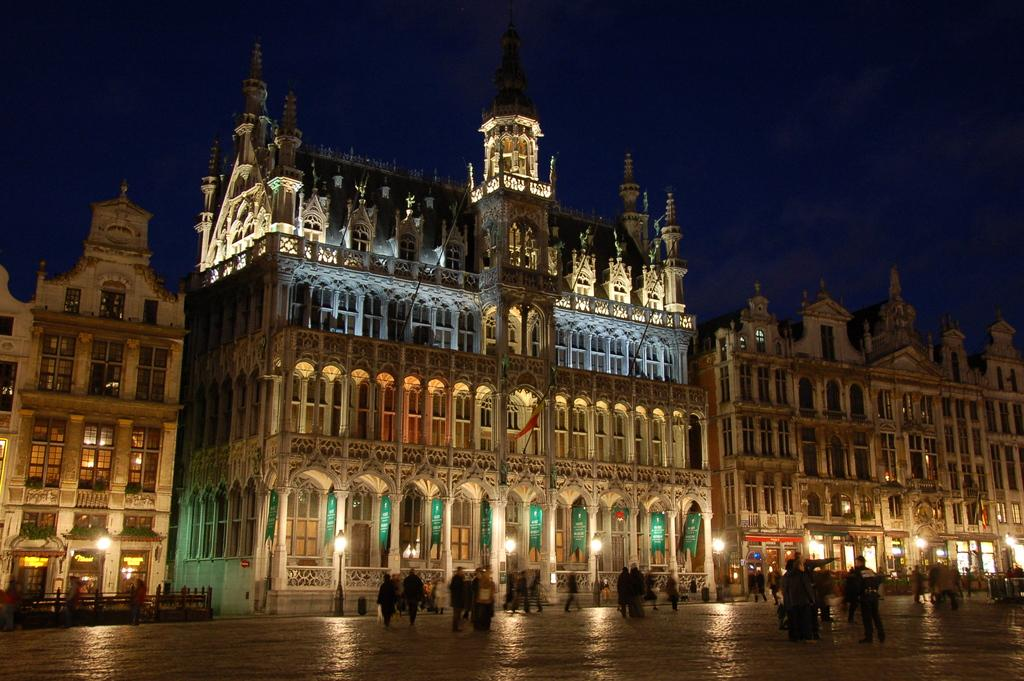What type of building is in the image? There is a palace in the image. What can be seen at the top of the image? The sky is visible at the top of the image. What is the source of light in the image? There is light in the image, but the specific source is not mentioned. What are the people in the image doing? There are persons walking on the road in the image. What type of tent is set up for the meal in the image? There is no tent or meal present in the image; it features a palace and people walking on the road. 